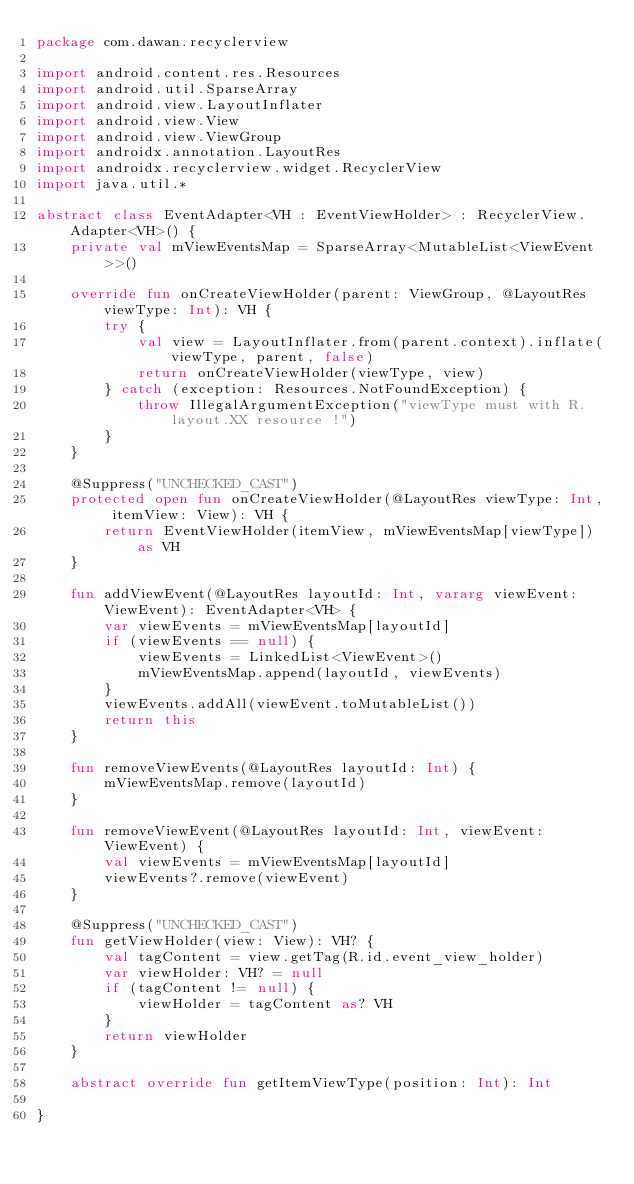Convert code to text. <code><loc_0><loc_0><loc_500><loc_500><_Kotlin_>package com.dawan.recyclerview

import android.content.res.Resources
import android.util.SparseArray
import android.view.LayoutInflater
import android.view.View
import android.view.ViewGroup
import androidx.annotation.LayoutRes
import androidx.recyclerview.widget.RecyclerView
import java.util.*

abstract class EventAdapter<VH : EventViewHolder> : RecyclerView.Adapter<VH>() {
    private val mViewEventsMap = SparseArray<MutableList<ViewEvent>>()

    override fun onCreateViewHolder(parent: ViewGroup, @LayoutRes viewType: Int): VH {
        try {
            val view = LayoutInflater.from(parent.context).inflate(viewType, parent, false)
            return onCreateViewHolder(viewType, view)
        } catch (exception: Resources.NotFoundException) {
            throw IllegalArgumentException("viewType must with R.layout.XX resource !")
        }
    }

    @Suppress("UNCHECKED_CAST")
    protected open fun onCreateViewHolder(@LayoutRes viewType: Int, itemView: View): VH {
        return EventViewHolder(itemView, mViewEventsMap[viewType]) as VH
    }

    fun addViewEvent(@LayoutRes layoutId: Int, vararg viewEvent: ViewEvent): EventAdapter<VH> {
        var viewEvents = mViewEventsMap[layoutId]
        if (viewEvents == null) {
            viewEvents = LinkedList<ViewEvent>()
            mViewEventsMap.append(layoutId, viewEvents)
        }
        viewEvents.addAll(viewEvent.toMutableList())
        return this
    }

    fun removeViewEvents(@LayoutRes layoutId: Int) {
        mViewEventsMap.remove(layoutId)
    }

    fun removeViewEvent(@LayoutRes layoutId: Int, viewEvent: ViewEvent) {
        val viewEvents = mViewEventsMap[layoutId]
        viewEvents?.remove(viewEvent)
    }

    @Suppress("UNCHECKED_CAST")
    fun getViewHolder(view: View): VH? {
        val tagContent = view.getTag(R.id.event_view_holder)
        var viewHolder: VH? = null
        if (tagContent != null) {
            viewHolder = tagContent as? VH
        }
        return viewHolder
    }

    abstract override fun getItemViewType(position: Int): Int

}</code> 